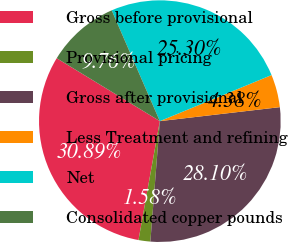<chart> <loc_0><loc_0><loc_500><loc_500><pie_chart><fcel>Gross before provisional<fcel>Provisional pricing<fcel>Gross after provisional<fcel>Less Treatment and refining<fcel>Net<fcel>Consolidated copper pounds<nl><fcel>30.89%<fcel>1.58%<fcel>28.1%<fcel>4.38%<fcel>25.3%<fcel>9.76%<nl></chart> 